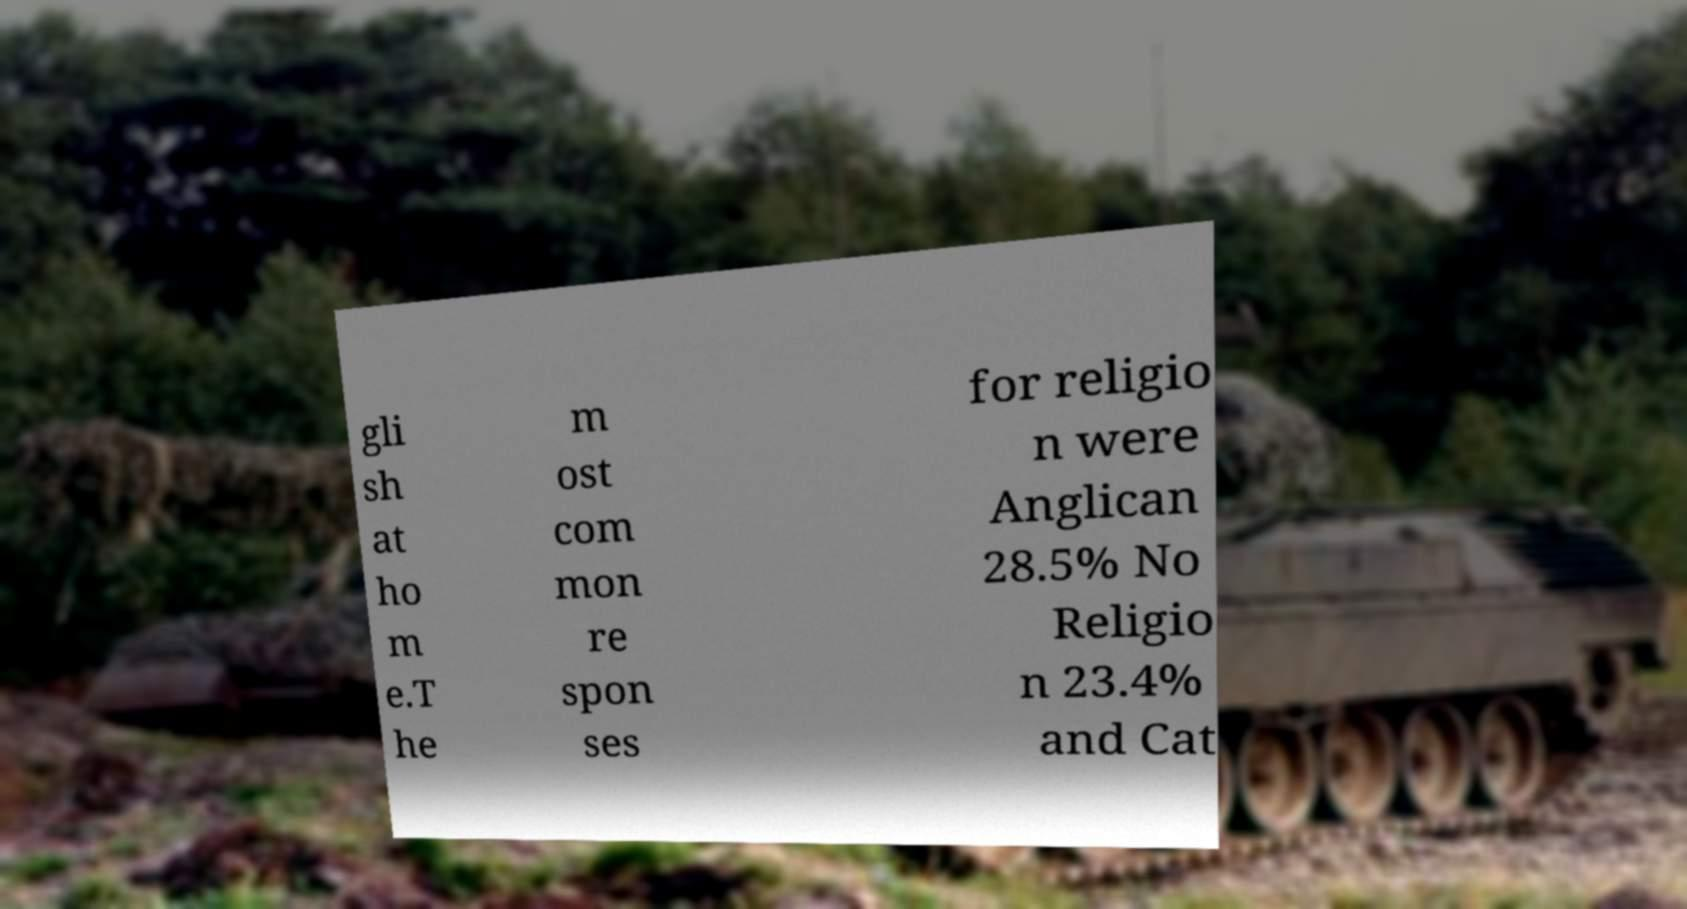For documentation purposes, I need the text within this image transcribed. Could you provide that? gli sh at ho m e.T he m ost com mon re spon ses for religio n were Anglican 28.5% No Religio n 23.4% and Cat 